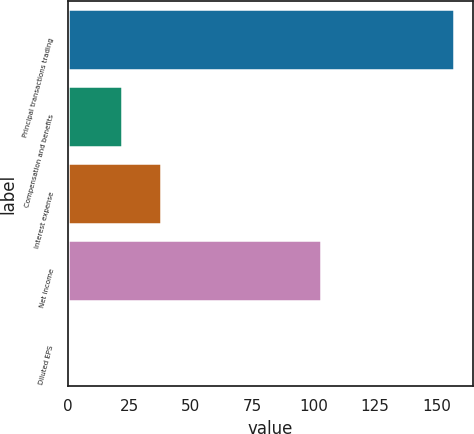<chart> <loc_0><loc_0><loc_500><loc_500><bar_chart><fcel>Principal transactions trading<fcel>Compensation and benefits<fcel>Interest expense<fcel>Net income<fcel>Diluted EPS<nl><fcel>157<fcel>22<fcel>37.69<fcel>103<fcel>0.1<nl></chart> 